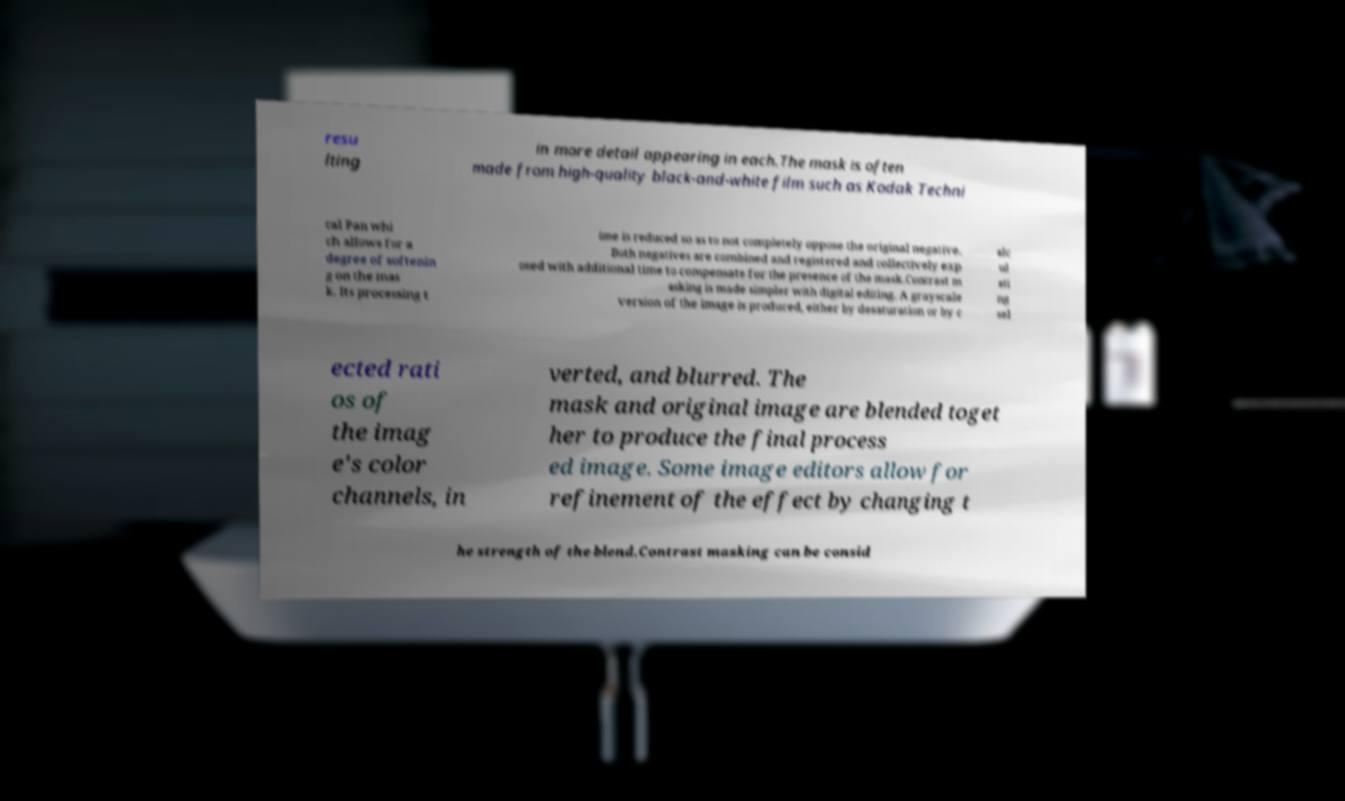For documentation purposes, I need the text within this image transcribed. Could you provide that? resu lting in more detail appearing in each.The mask is often made from high-quality black-and-white film such as Kodak Techni cal Pan whi ch allows for a degree of softenin g on the mas k. Its processing t ime is reduced so as to not completely oppose the original negative. Both negatives are combined and registered and collectively exp osed with additional time to compensate for the presence of the mask.Contrast m asking is made simpler with digital editing. A grayscale version of the image is produced, either by desaturation or by c alc ul ati ng sel ected rati os of the imag e's color channels, in verted, and blurred. The mask and original image are blended toget her to produce the final process ed image. Some image editors allow for refinement of the effect by changing t he strength of the blend.Contrast masking can be consid 